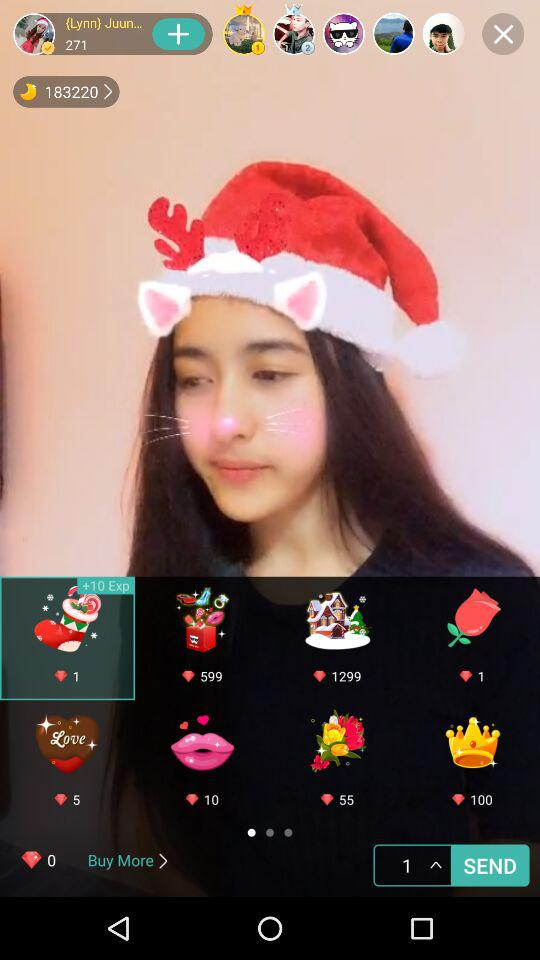How many people like the pic?
When the provided information is insufficient, respond with <no answer>. <no answer> 